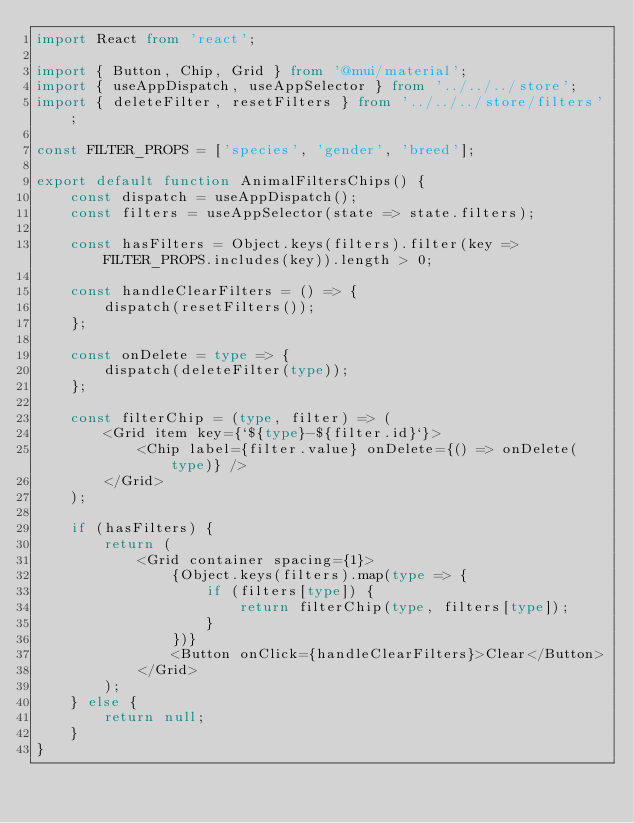Convert code to text. <code><loc_0><loc_0><loc_500><loc_500><_TypeScript_>import React from 'react';

import { Button, Chip, Grid } from '@mui/material';
import { useAppDispatch, useAppSelector } from '../../../store';
import { deleteFilter, resetFilters } from '../../../store/filters';

const FILTER_PROPS = ['species', 'gender', 'breed'];

export default function AnimalFiltersChips() {
    const dispatch = useAppDispatch();
    const filters = useAppSelector(state => state.filters);

    const hasFilters = Object.keys(filters).filter(key => FILTER_PROPS.includes(key)).length > 0;

    const handleClearFilters = () => {
        dispatch(resetFilters());
    };

    const onDelete = type => {
        dispatch(deleteFilter(type));
    };

    const filterChip = (type, filter) => (
        <Grid item key={`${type}-${filter.id}`}>
            <Chip label={filter.value} onDelete={() => onDelete(type)} />
        </Grid>
    );

    if (hasFilters) {
        return (
            <Grid container spacing={1}>
                {Object.keys(filters).map(type => {
                    if (filters[type]) {
                        return filterChip(type, filters[type]);
                    }
                })}
                <Button onClick={handleClearFilters}>Clear</Button>
            </Grid>
        );
    } else {
        return null;
    }
}
</code> 